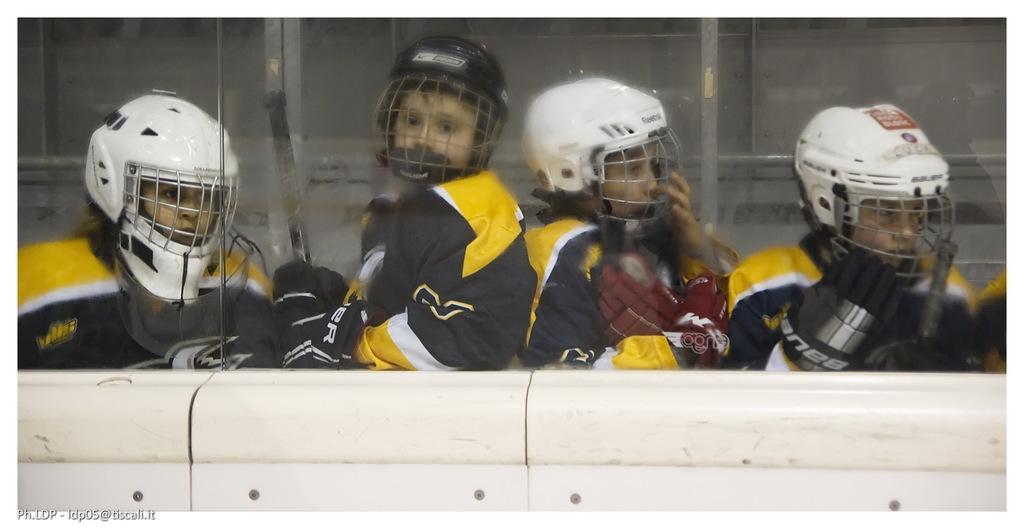How would you summarize this image in a sentence or two? In this image in the center there are some persons who are wearing some costumes, and they are wearing helmets. And at the bottom it looks like a wall, and in the background there is a glass window. 